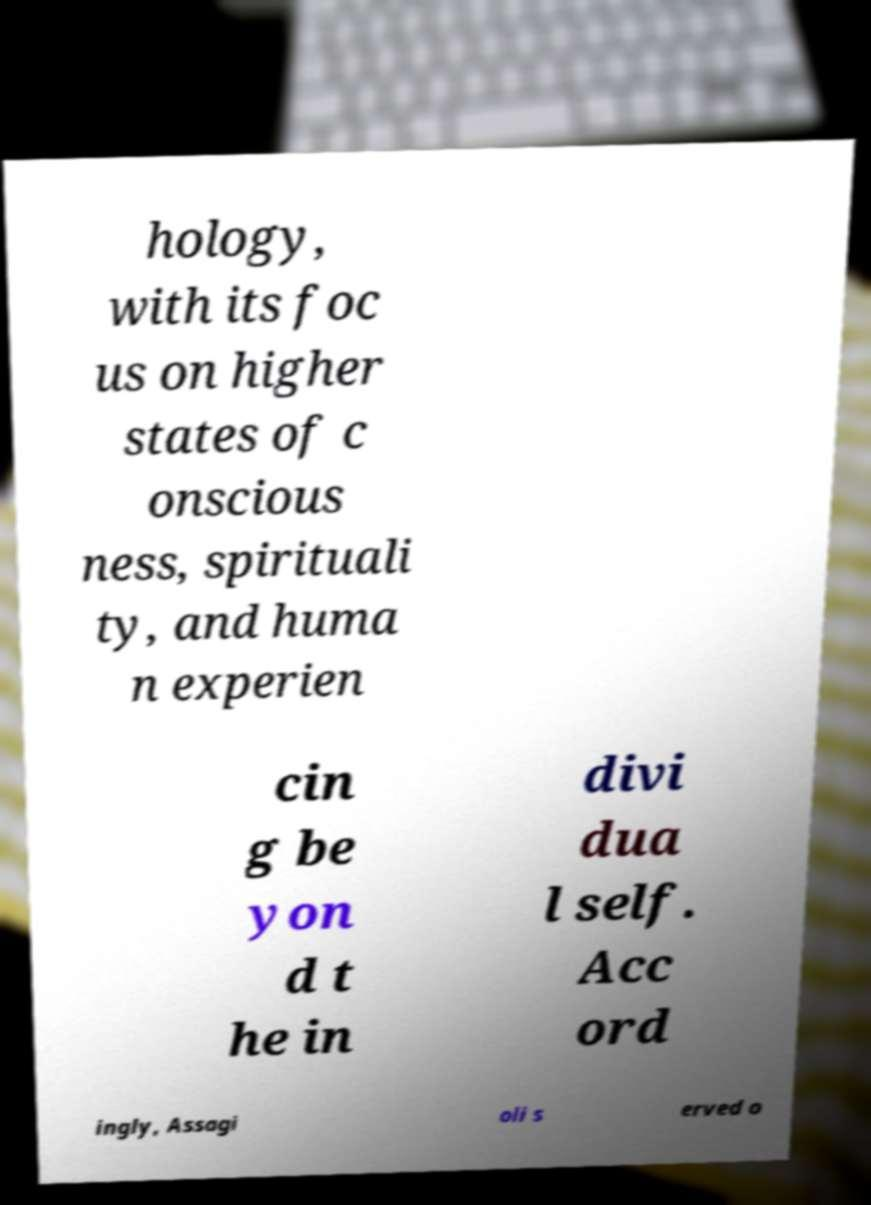Could you extract and type out the text from this image? hology, with its foc us on higher states of c onscious ness, spirituali ty, and huma n experien cin g be yon d t he in divi dua l self. Acc ord ingly, Assagi oli s erved o 